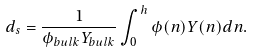<formula> <loc_0><loc_0><loc_500><loc_500>d _ { s } = \frac { 1 } { \phi _ { b u l k } Y _ { b u l k } } \int ^ { h } _ { 0 } \phi ( n ) Y ( n ) d n .</formula> 